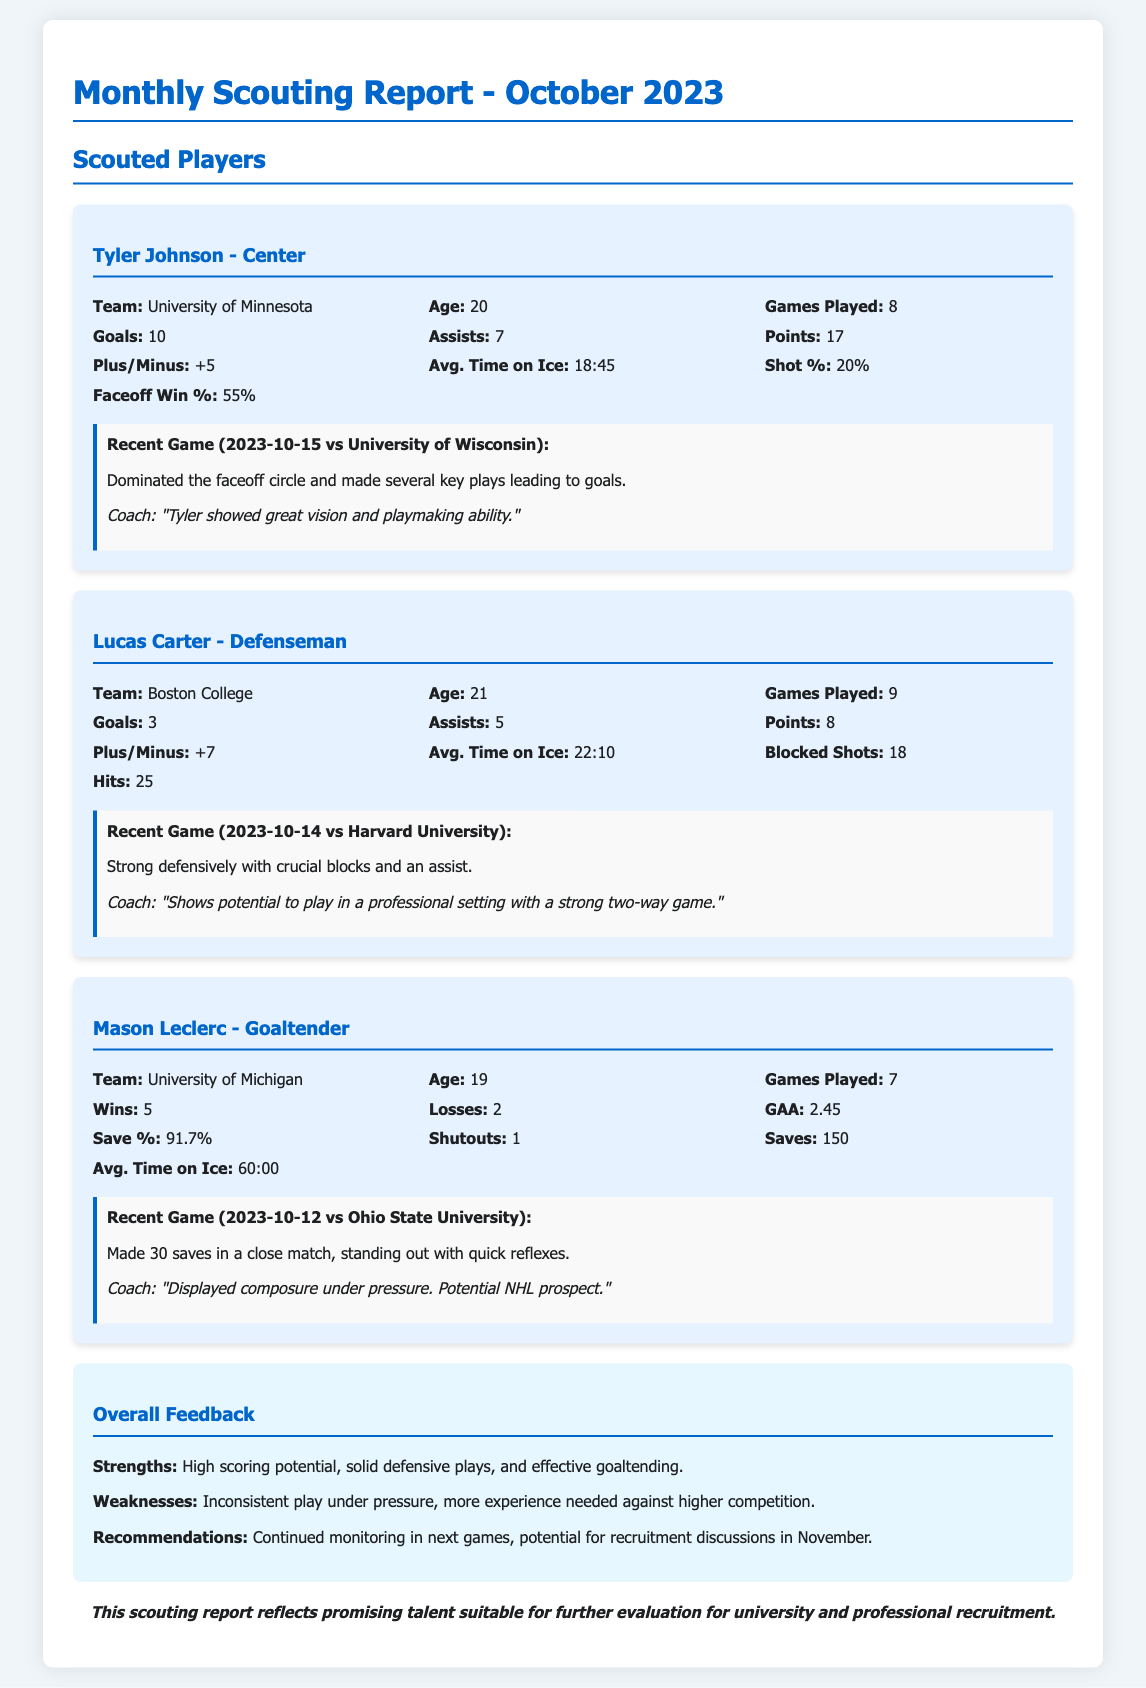What is the title of the report? The title of the report is specified at the beginning of the document, indicating it is a monthly scouting report for October 2023.
Answer: Monthly Scouting Report - October 2023 Who is the player featured as a Center? The document lists player positions under the player cards, specifically stating Tyler Johnson as a Center.
Answer: Tyler Johnson How many goals did Tyler Johnson score? The number of goals scored by Tyler Johnson is presented within his player statistics in the document.
Answer: 10 What is Mason Leclerc's Save Percentage? The Save Percentage of Mason Leclerc is mentioned in the goaltending statistics section, providing specific performance metrics.
Answer: 91.7% What strengths are noted in the overall feedback? The overall feedback section summarizes strengths as high scoring potential, solid defensive plays, and effective goaltending.
Answer: High scoring potential, solid defensive plays, effective goaltending What recent game did Lucas Carter play? The document provides information about recent games for players, specifying that Lucas Carter played against Harvard University on October 14, 2023.
Answer: Harvard University What was Mason Leclerc's Goals Against Average? The Goals Against Average (GAA) for Mason Leclerc is included in his goaltender statistics section, showing his performance in games.
Answer: 2.45 How many assists did Lucas Carter have? The assists contributed by Lucas Carter are listed among his player statistics, indicating his contributions to team scoring.
Answer: 5 What are the recommendations made in the report? Recommendations for player evaluations are outlined in the overall feedback section, indicating strategies for future assessments.
Answer: Continued monitoring in next games, potential for recruitment discussions in November 